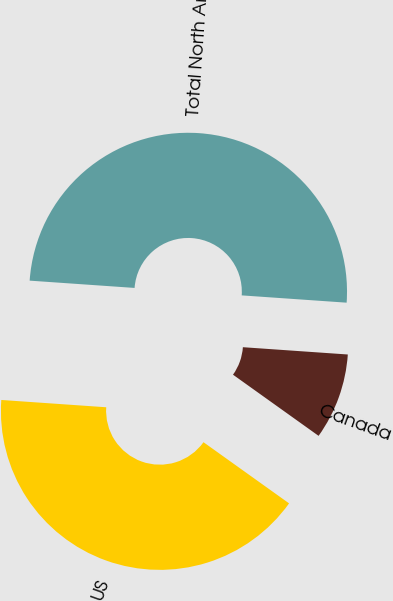Convert chart to OTSL. <chart><loc_0><loc_0><loc_500><loc_500><pie_chart><fcel>US<fcel>Canada<fcel>Total North America<nl><fcel>41.23%<fcel>8.77%<fcel>50.0%<nl></chart> 